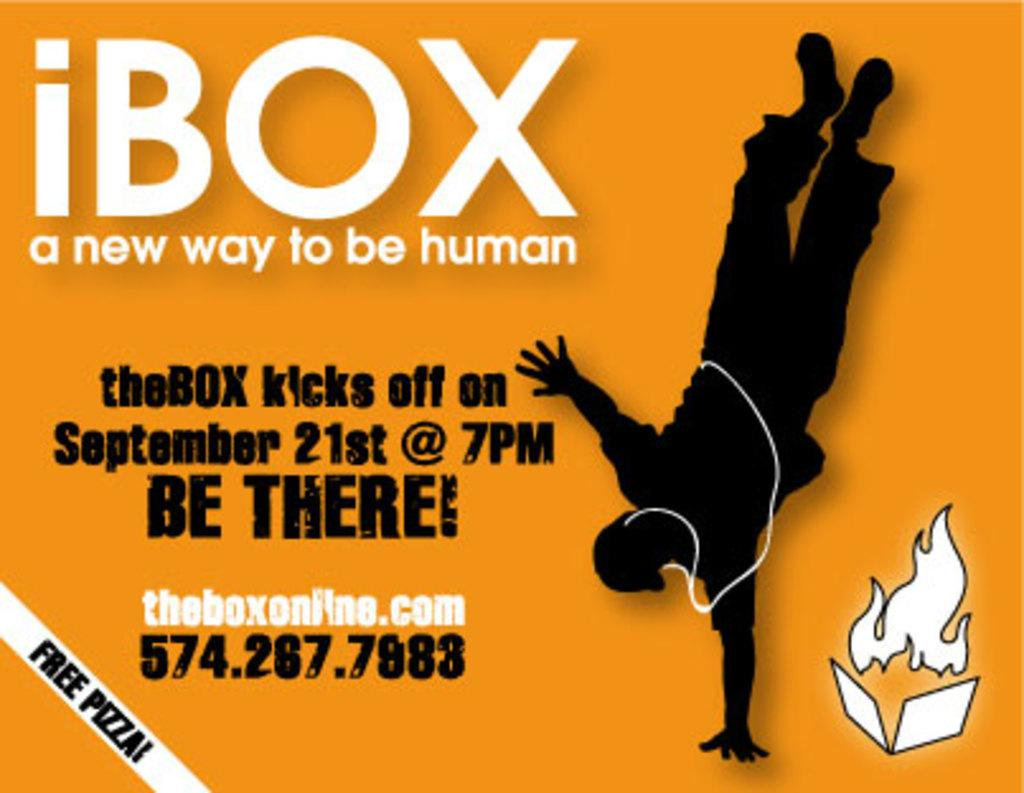<image>
Render a clear and concise summary of the photo. an advertisement for iBox, taking place on September 21st and offering free pizza 